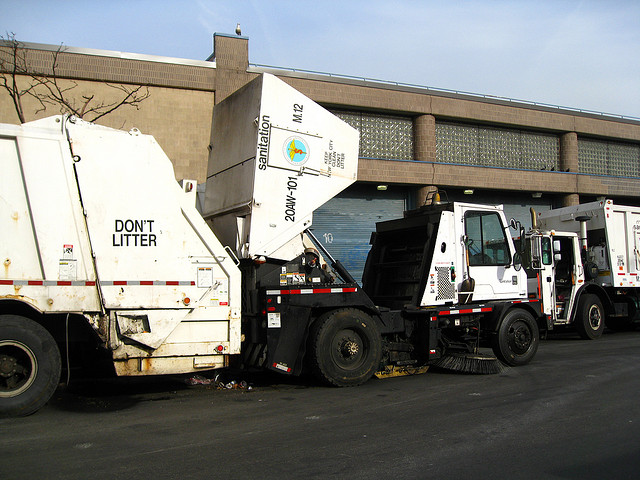Identify the text displayed in this image. DONT LITTER 20AW 101 Sanitation M12 10 CITY 